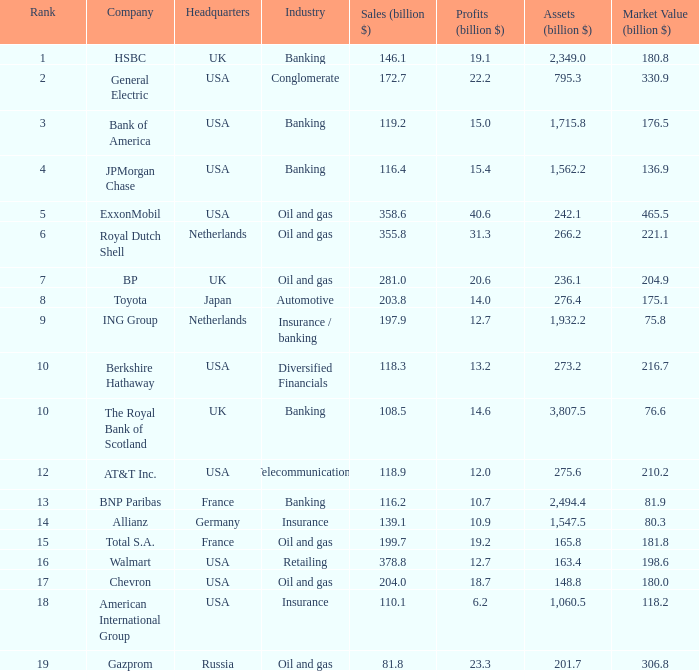What is the billion-dollar profit amount for berkshire hathaway? 13.2. 